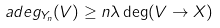<formula> <loc_0><loc_0><loc_500><loc_500>\ a d e g _ { Y _ { n } } ( V ) \geq n \lambda \deg ( V \to X )</formula> 